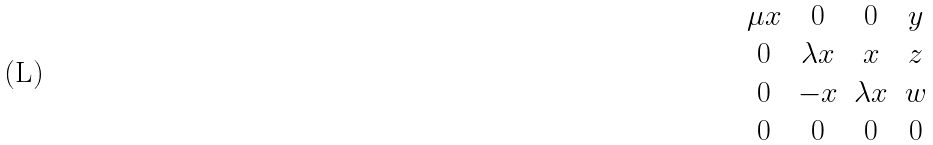<formula> <loc_0><loc_0><loc_500><loc_500>\begin{matrix} \mu x & 0 & 0 & y \\ 0 & \lambda x & x & z \\ 0 & - x & \lambda x & w \\ 0 & 0 & 0 & 0 \end{matrix}</formula> 